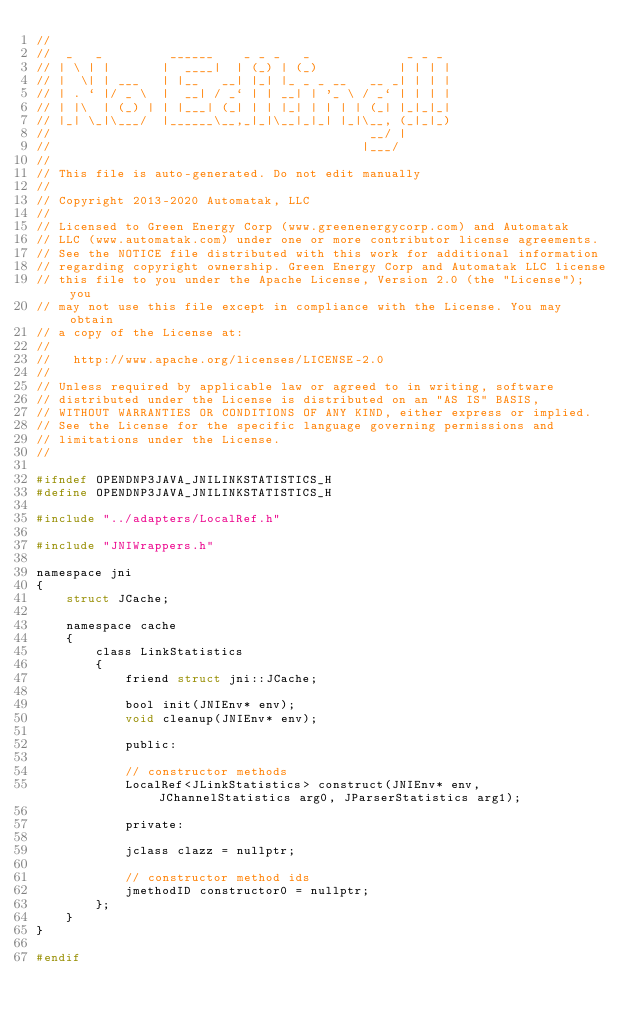<code> <loc_0><loc_0><loc_500><loc_500><_C_>//
//  _   _         ______    _ _ _   _             _ _ _
// | \ | |       |  ____|  | (_) | (_)           | | | |
// |  \| | ___   | |__   __| |_| |_ _ _ __   __ _| | | |
// | . ` |/ _ \  |  __| / _` | | __| | '_ \ / _` | | | |
// | |\  | (_) | | |___| (_| | | |_| | | | | (_| |_|_|_|
// |_| \_|\___/  |______\__,_|_|\__|_|_| |_|\__, (_|_|_)
//                                           __/ |
//                                          |___/
// 
// This file is auto-generated. Do not edit manually
// 
// Copyright 2013-2020 Automatak, LLC
// 
// Licensed to Green Energy Corp (www.greenenergycorp.com) and Automatak
// LLC (www.automatak.com) under one or more contributor license agreements.
// See the NOTICE file distributed with this work for additional information
// regarding copyright ownership. Green Energy Corp and Automatak LLC license
// this file to you under the Apache License, Version 2.0 (the "License"); you
// may not use this file except in compliance with the License. You may obtain
// a copy of the License at:
// 
//   http://www.apache.org/licenses/LICENSE-2.0
// 
// Unless required by applicable law or agreed to in writing, software
// distributed under the License is distributed on an "AS IS" BASIS,
// WITHOUT WARRANTIES OR CONDITIONS OF ANY KIND, either express or implied.
// See the License for the specific language governing permissions and
// limitations under the License.
//

#ifndef OPENDNP3JAVA_JNILINKSTATISTICS_H
#define OPENDNP3JAVA_JNILINKSTATISTICS_H

#include "../adapters/LocalRef.h"

#include "JNIWrappers.h"

namespace jni
{
    struct JCache;

    namespace cache
    {
        class LinkStatistics
        {
            friend struct jni::JCache;

            bool init(JNIEnv* env);
            void cleanup(JNIEnv* env);

            public:

            // constructor methods
            LocalRef<JLinkStatistics> construct(JNIEnv* env, JChannelStatistics arg0, JParserStatistics arg1);

            private:

            jclass clazz = nullptr;

            // constructor method ids
            jmethodID constructor0 = nullptr;
        };
    }
}

#endif
</code> 